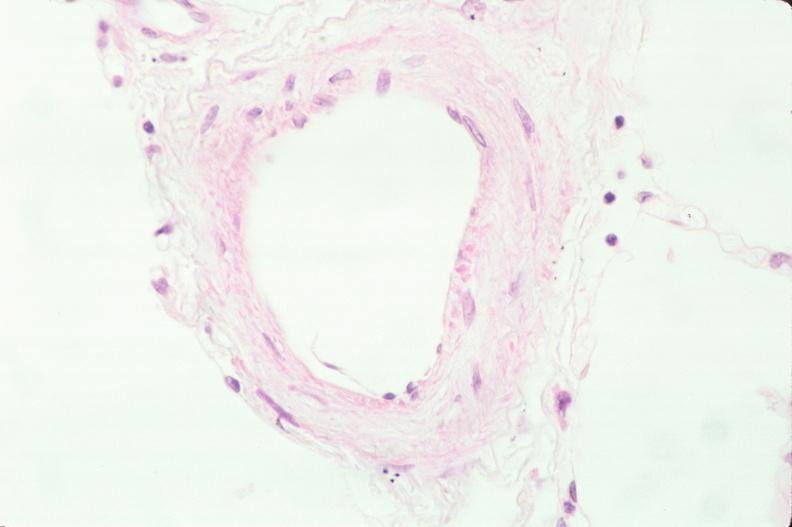does this image show lung, phlebosclerosis?
Answer the question using a single word or phrase. Yes 